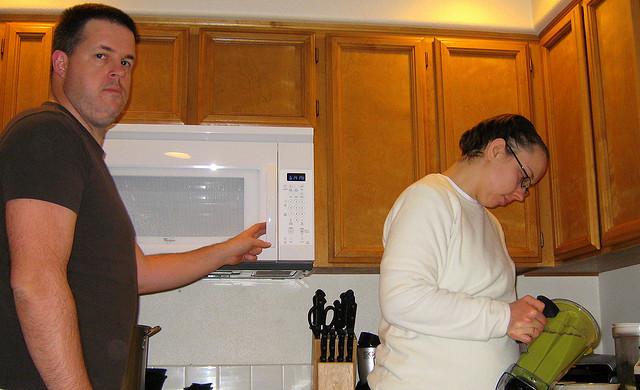Is the guy trying to open the microwave?
Concise answer only. Yes. What color are the cabinets?
Be succinct. Brown. What color is the item in his blender?
Write a very short answer. Green. What is in the blender?
Give a very brief answer. Smoothie. What color is her sweater?
Keep it brief. White. 